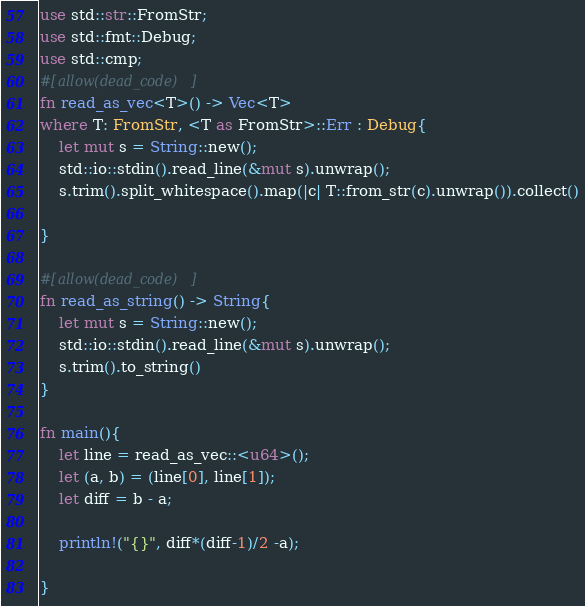Convert code to text. <code><loc_0><loc_0><loc_500><loc_500><_Rust_>use std::str::FromStr;
use std::fmt::Debug;
use std::cmp;
#[allow(dead_code)]
fn read_as_vec<T>() -> Vec<T>
where T: FromStr, <T as FromStr>::Err : Debug{
    let mut s = String::new();
    std::io::stdin().read_line(&mut s).unwrap();
    s.trim().split_whitespace().map(|c| T::from_str(c).unwrap()).collect()

}

#[allow(dead_code)]
fn read_as_string() -> String{
    let mut s = String::new();
    std::io::stdin().read_line(&mut s).unwrap();
    s.trim().to_string()
}

fn main(){
    let line = read_as_vec::<u64>();
    let (a, b) = (line[0], line[1]);
    let diff = b - a;

    println!("{}", diff*(diff-1)/2 -a);

}
</code> 